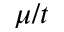<formula> <loc_0><loc_0><loc_500><loc_500>\mu / t</formula> 